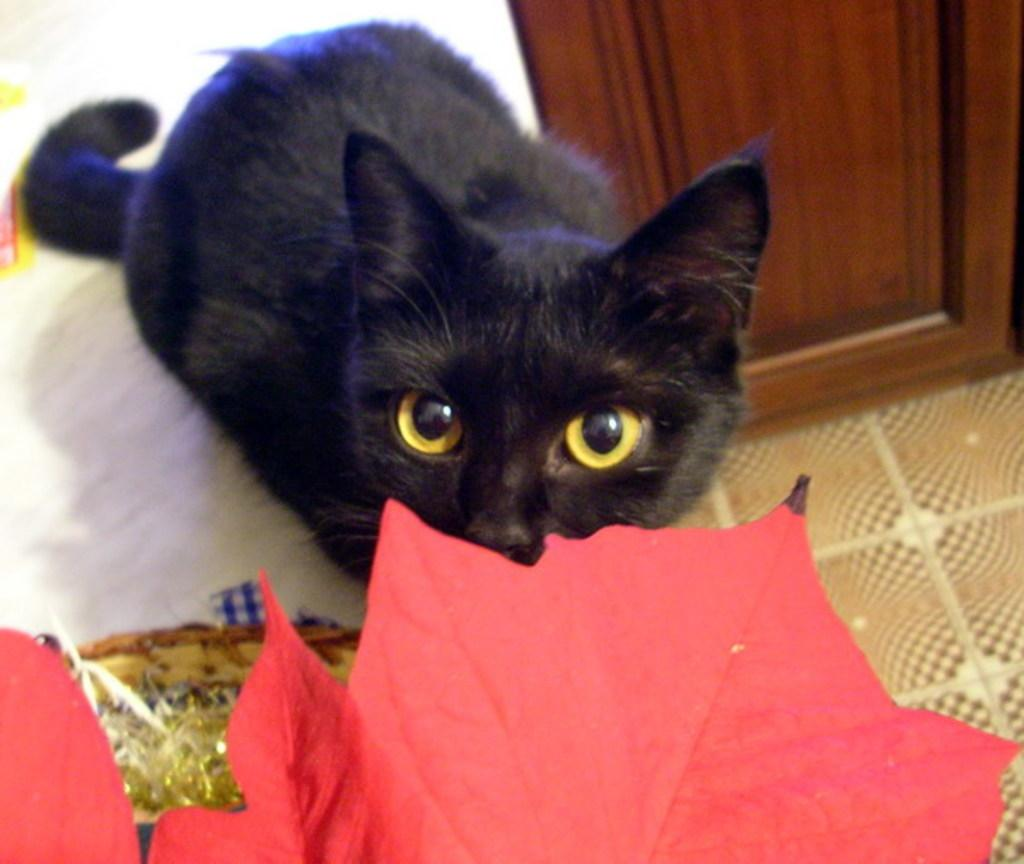What is the main subject in the center of the image? There is a cat in the center of the image. What can be seen in the background of the image? There are leaves and other objects visible in the background of the image. Can you describe the door in the image? There is a door in the image, but its specific characteristics are not mentioned in the facts. What is at the bottom of the image? There is a floor at the bottom of the image. How many dimes are on the cat's head in the image? There is no mention of dimes or a head in the image, so it cannot be determined if any dimes are present. 